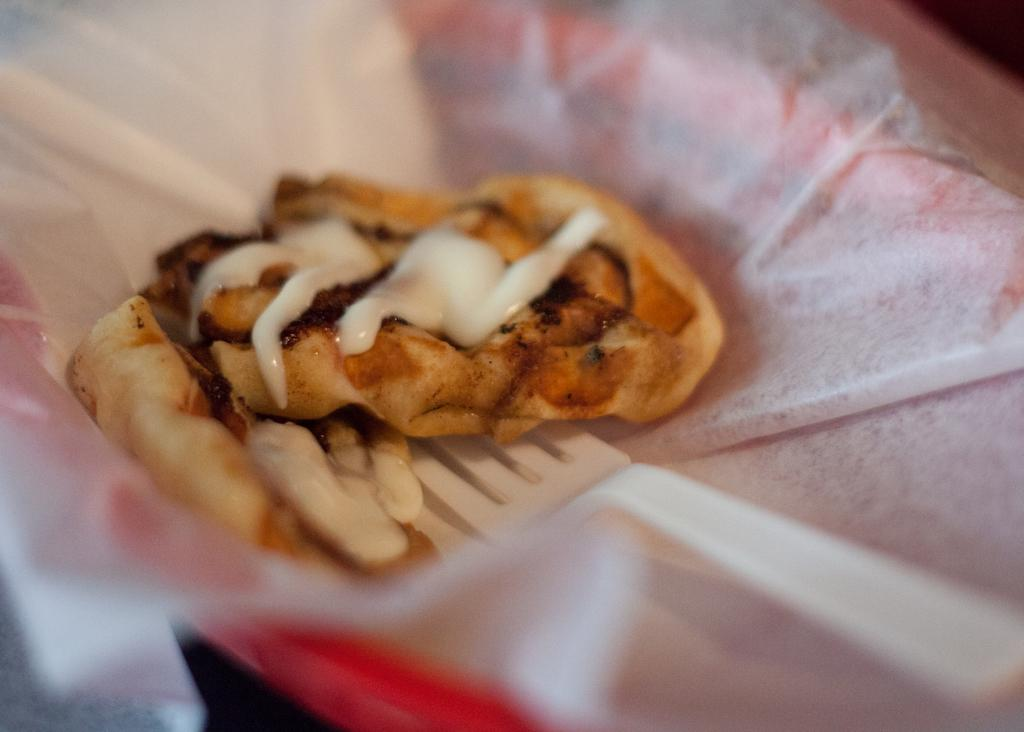What is in the bowl that is visible in the image? There is food in a bowl in the image. What other item can be seen in the image besides the bowl of food? There is a tissue in the image. What utensil is used with the food in the bowl? There is a fork in the bowl. What book is the person reading in the image? There is no person or book present in the image; it only features a bowl of food, a tissue, and a fork. 